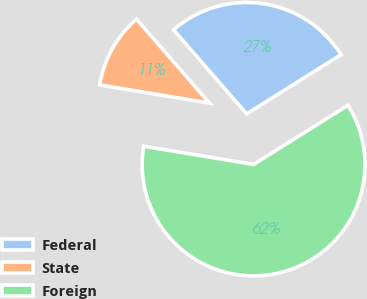<chart> <loc_0><loc_0><loc_500><loc_500><pie_chart><fcel>Federal<fcel>State<fcel>Foreign<nl><fcel>27.48%<fcel>10.99%<fcel>61.52%<nl></chart> 